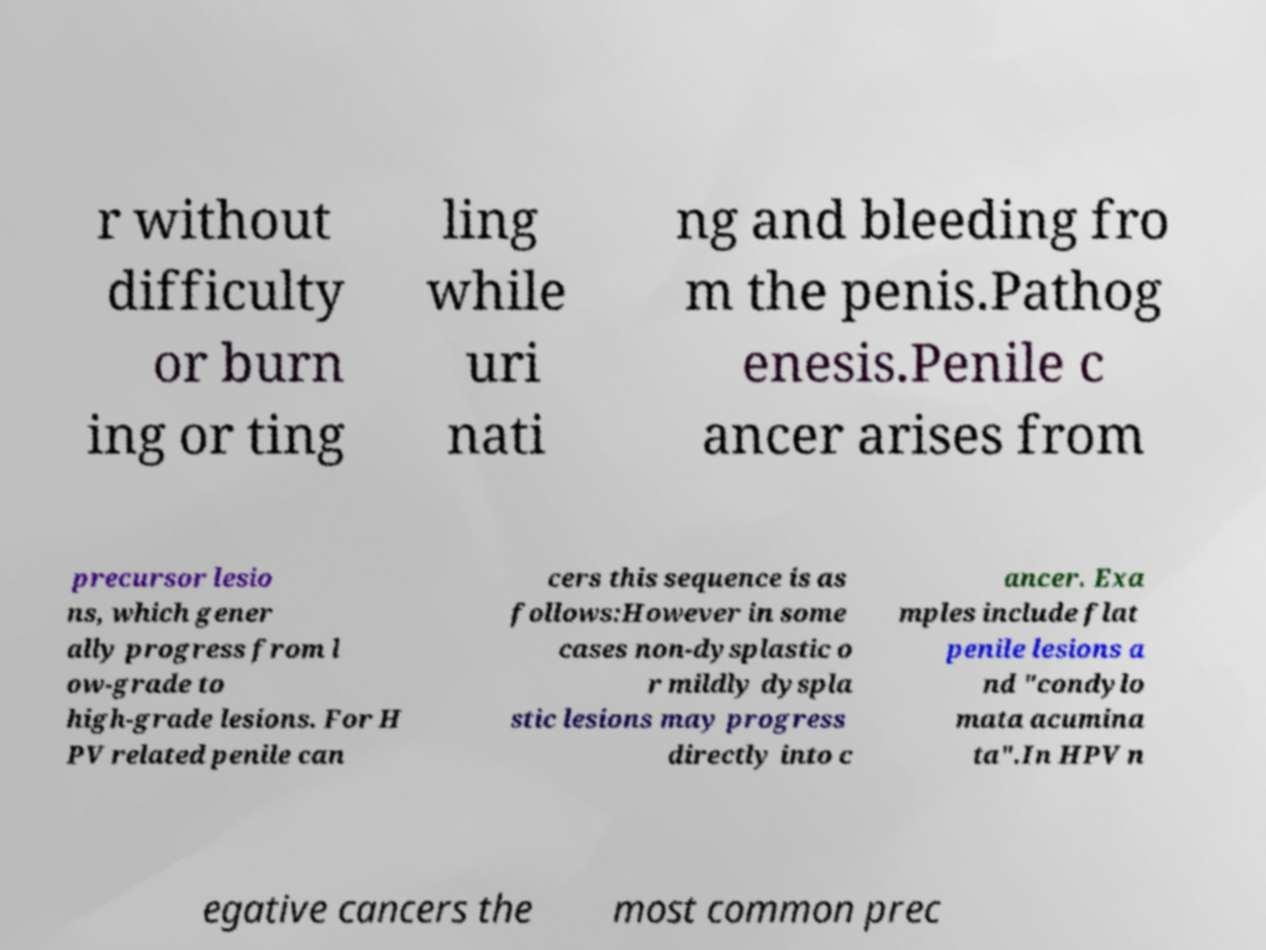I need the written content from this picture converted into text. Can you do that? r without difficulty or burn ing or ting ling while uri nati ng and bleeding fro m the penis.Pathog enesis.Penile c ancer arises from precursor lesio ns, which gener ally progress from l ow-grade to high-grade lesions. For H PV related penile can cers this sequence is as follows:However in some cases non-dysplastic o r mildly dyspla stic lesions may progress directly into c ancer. Exa mples include flat penile lesions a nd "condylo mata acumina ta".In HPV n egative cancers the most common prec 